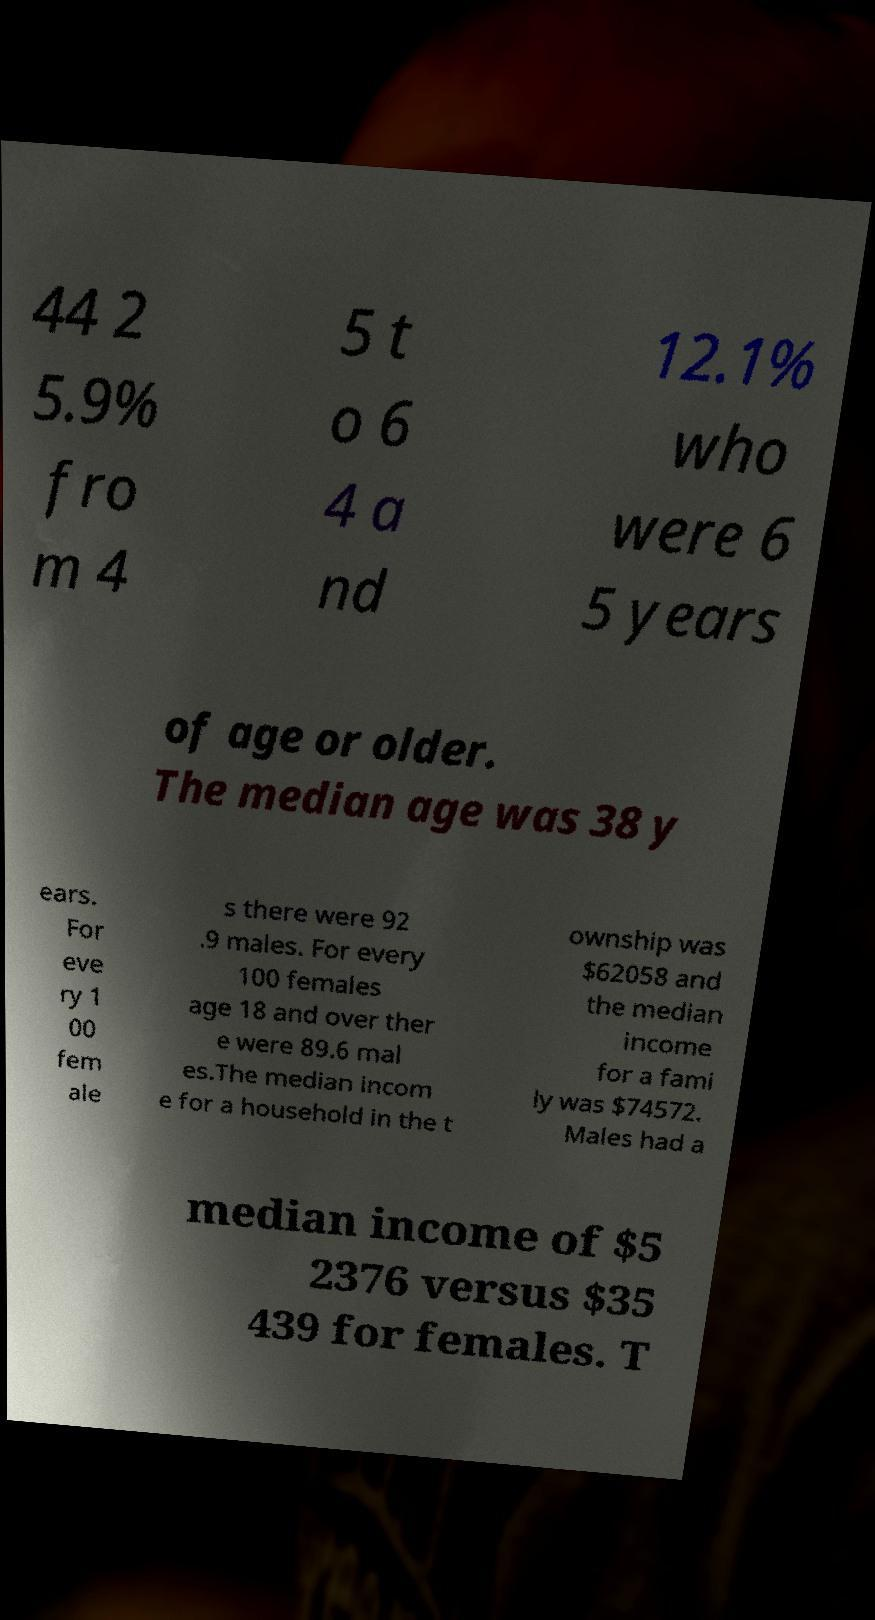Can you read and provide the text displayed in the image?This photo seems to have some interesting text. Can you extract and type it out for me? 44 2 5.9% fro m 4 5 t o 6 4 a nd 12.1% who were 6 5 years of age or older. The median age was 38 y ears. For eve ry 1 00 fem ale s there were 92 .9 males. For every 100 females age 18 and over ther e were 89.6 mal es.The median incom e for a household in the t ownship was $62058 and the median income for a fami ly was $74572. Males had a median income of $5 2376 versus $35 439 for females. T 